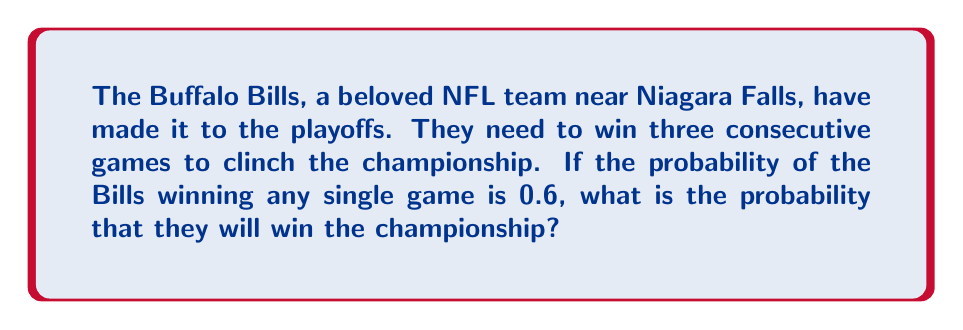Can you answer this question? Let's approach this step-by-step:

1) The Bills need to win three games in a row to win the championship.

2) The probability of winning each game is 0.6 (or 60%).

3) To find the probability of winning all three games, we need to multiply the probabilities of each individual event (since these are independent events).

4) The probability is calculated as follows:

   $$P(\text{winning championship}) = P(\text{win game 1}) \times P(\text{win game 2}) \times P(\text{win game 3})$$

5) Substituting the given probability:

   $$P(\text{winning championship}) = 0.6 \times 0.6 \times 0.6$$

6) Simplifying:

   $$P(\text{winning championship}) = 0.6^3 = 0.216$$

Therefore, the probability of the Buffalo Bills winning the championship is 0.216 or 21.6%.
Answer: $0.216$ or $21.6\%$ 